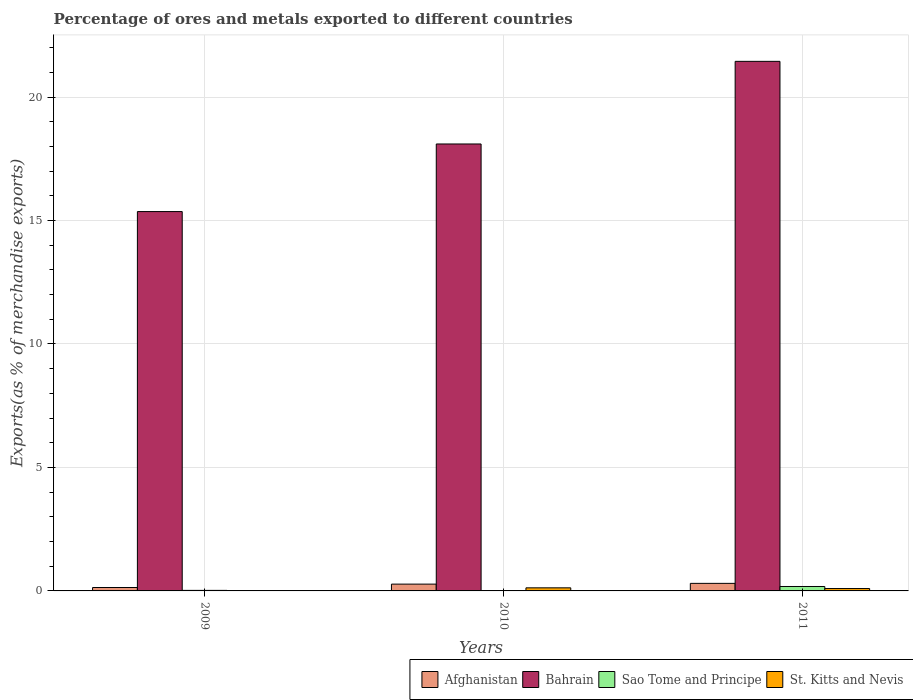How many different coloured bars are there?
Your response must be concise. 4. Are the number of bars on each tick of the X-axis equal?
Give a very brief answer. Yes. What is the percentage of exports to different countries in St. Kitts and Nevis in 2010?
Make the answer very short. 0.13. Across all years, what is the maximum percentage of exports to different countries in Afghanistan?
Your answer should be very brief. 0.31. Across all years, what is the minimum percentage of exports to different countries in Sao Tome and Principe?
Your response must be concise. 0.01. In which year was the percentage of exports to different countries in St. Kitts and Nevis maximum?
Provide a succinct answer. 2010. In which year was the percentage of exports to different countries in Bahrain minimum?
Make the answer very short. 2009. What is the total percentage of exports to different countries in Sao Tome and Principe in the graph?
Ensure brevity in your answer.  0.22. What is the difference between the percentage of exports to different countries in St. Kitts and Nevis in 2010 and that in 2011?
Offer a terse response. 0.03. What is the difference between the percentage of exports to different countries in Sao Tome and Principe in 2011 and the percentage of exports to different countries in Bahrain in 2010?
Make the answer very short. -17.92. What is the average percentage of exports to different countries in Afghanistan per year?
Offer a very short reply. 0.24. In the year 2010, what is the difference between the percentage of exports to different countries in Afghanistan and percentage of exports to different countries in Sao Tome and Principe?
Give a very brief answer. 0.26. What is the ratio of the percentage of exports to different countries in Afghanistan in 2009 to that in 2011?
Offer a very short reply. 0.45. Is the percentage of exports to different countries in St. Kitts and Nevis in 2009 less than that in 2010?
Your response must be concise. Yes. What is the difference between the highest and the second highest percentage of exports to different countries in St. Kitts and Nevis?
Your answer should be very brief. 0.03. What is the difference between the highest and the lowest percentage of exports to different countries in St. Kitts and Nevis?
Ensure brevity in your answer.  0.13. What does the 3rd bar from the left in 2010 represents?
Make the answer very short. Sao Tome and Principe. What does the 2nd bar from the right in 2011 represents?
Provide a short and direct response. Sao Tome and Principe. Are all the bars in the graph horizontal?
Make the answer very short. No. Does the graph contain any zero values?
Ensure brevity in your answer.  No. Does the graph contain grids?
Your answer should be compact. Yes. Where does the legend appear in the graph?
Ensure brevity in your answer.  Bottom right. What is the title of the graph?
Make the answer very short. Percentage of ores and metals exported to different countries. What is the label or title of the Y-axis?
Ensure brevity in your answer.  Exports(as % of merchandise exports). What is the Exports(as % of merchandise exports) in Afghanistan in 2009?
Your answer should be compact. 0.14. What is the Exports(as % of merchandise exports) in Bahrain in 2009?
Give a very brief answer. 15.36. What is the Exports(as % of merchandise exports) of Sao Tome and Principe in 2009?
Give a very brief answer. 0.02. What is the Exports(as % of merchandise exports) in St. Kitts and Nevis in 2009?
Ensure brevity in your answer.  5.4969756098276e-5. What is the Exports(as % of merchandise exports) in Afghanistan in 2010?
Your answer should be compact. 0.28. What is the Exports(as % of merchandise exports) of Bahrain in 2010?
Offer a terse response. 18.1. What is the Exports(as % of merchandise exports) of Sao Tome and Principe in 2010?
Your answer should be very brief. 0.01. What is the Exports(as % of merchandise exports) in St. Kitts and Nevis in 2010?
Keep it short and to the point. 0.13. What is the Exports(as % of merchandise exports) of Afghanistan in 2011?
Make the answer very short. 0.31. What is the Exports(as % of merchandise exports) of Bahrain in 2011?
Your answer should be compact. 21.45. What is the Exports(as % of merchandise exports) of Sao Tome and Principe in 2011?
Make the answer very short. 0.18. What is the Exports(as % of merchandise exports) of St. Kitts and Nevis in 2011?
Provide a short and direct response. 0.1. Across all years, what is the maximum Exports(as % of merchandise exports) in Afghanistan?
Offer a terse response. 0.31. Across all years, what is the maximum Exports(as % of merchandise exports) of Bahrain?
Make the answer very short. 21.45. Across all years, what is the maximum Exports(as % of merchandise exports) of Sao Tome and Principe?
Provide a succinct answer. 0.18. Across all years, what is the maximum Exports(as % of merchandise exports) in St. Kitts and Nevis?
Give a very brief answer. 0.13. Across all years, what is the minimum Exports(as % of merchandise exports) of Afghanistan?
Give a very brief answer. 0.14. Across all years, what is the minimum Exports(as % of merchandise exports) in Bahrain?
Your answer should be very brief. 15.36. Across all years, what is the minimum Exports(as % of merchandise exports) in Sao Tome and Principe?
Your response must be concise. 0.01. Across all years, what is the minimum Exports(as % of merchandise exports) in St. Kitts and Nevis?
Ensure brevity in your answer.  5.4969756098276e-5. What is the total Exports(as % of merchandise exports) in Afghanistan in the graph?
Offer a very short reply. 0.72. What is the total Exports(as % of merchandise exports) of Bahrain in the graph?
Your response must be concise. 54.91. What is the total Exports(as % of merchandise exports) in Sao Tome and Principe in the graph?
Offer a very short reply. 0.22. What is the total Exports(as % of merchandise exports) of St. Kitts and Nevis in the graph?
Make the answer very short. 0.22. What is the difference between the Exports(as % of merchandise exports) in Afghanistan in 2009 and that in 2010?
Keep it short and to the point. -0.14. What is the difference between the Exports(as % of merchandise exports) of Bahrain in 2009 and that in 2010?
Keep it short and to the point. -2.74. What is the difference between the Exports(as % of merchandise exports) of Sao Tome and Principe in 2009 and that in 2010?
Offer a very short reply. 0.01. What is the difference between the Exports(as % of merchandise exports) of St. Kitts and Nevis in 2009 and that in 2010?
Your answer should be compact. -0.13. What is the difference between the Exports(as % of merchandise exports) in Afghanistan in 2009 and that in 2011?
Offer a very short reply. -0.17. What is the difference between the Exports(as % of merchandise exports) in Bahrain in 2009 and that in 2011?
Provide a succinct answer. -6.08. What is the difference between the Exports(as % of merchandise exports) in Sao Tome and Principe in 2009 and that in 2011?
Your response must be concise. -0.16. What is the difference between the Exports(as % of merchandise exports) of St. Kitts and Nevis in 2009 and that in 2011?
Offer a terse response. -0.1. What is the difference between the Exports(as % of merchandise exports) of Afghanistan in 2010 and that in 2011?
Provide a short and direct response. -0.03. What is the difference between the Exports(as % of merchandise exports) of Bahrain in 2010 and that in 2011?
Your response must be concise. -3.35. What is the difference between the Exports(as % of merchandise exports) in Sao Tome and Principe in 2010 and that in 2011?
Offer a terse response. -0.16. What is the difference between the Exports(as % of merchandise exports) of St. Kitts and Nevis in 2010 and that in 2011?
Your answer should be very brief. 0.03. What is the difference between the Exports(as % of merchandise exports) in Afghanistan in 2009 and the Exports(as % of merchandise exports) in Bahrain in 2010?
Offer a very short reply. -17.96. What is the difference between the Exports(as % of merchandise exports) in Afghanistan in 2009 and the Exports(as % of merchandise exports) in Sao Tome and Principe in 2010?
Make the answer very short. 0.12. What is the difference between the Exports(as % of merchandise exports) of Afghanistan in 2009 and the Exports(as % of merchandise exports) of St. Kitts and Nevis in 2010?
Your answer should be very brief. 0.01. What is the difference between the Exports(as % of merchandise exports) in Bahrain in 2009 and the Exports(as % of merchandise exports) in Sao Tome and Principe in 2010?
Make the answer very short. 15.35. What is the difference between the Exports(as % of merchandise exports) in Bahrain in 2009 and the Exports(as % of merchandise exports) in St. Kitts and Nevis in 2010?
Provide a short and direct response. 15.24. What is the difference between the Exports(as % of merchandise exports) of Sao Tome and Principe in 2009 and the Exports(as % of merchandise exports) of St. Kitts and Nevis in 2010?
Your response must be concise. -0.1. What is the difference between the Exports(as % of merchandise exports) in Afghanistan in 2009 and the Exports(as % of merchandise exports) in Bahrain in 2011?
Your answer should be compact. -21.31. What is the difference between the Exports(as % of merchandise exports) of Afghanistan in 2009 and the Exports(as % of merchandise exports) of Sao Tome and Principe in 2011?
Offer a very short reply. -0.04. What is the difference between the Exports(as % of merchandise exports) in Afghanistan in 2009 and the Exports(as % of merchandise exports) in St. Kitts and Nevis in 2011?
Offer a very short reply. 0.04. What is the difference between the Exports(as % of merchandise exports) in Bahrain in 2009 and the Exports(as % of merchandise exports) in Sao Tome and Principe in 2011?
Provide a succinct answer. 15.18. What is the difference between the Exports(as % of merchandise exports) in Bahrain in 2009 and the Exports(as % of merchandise exports) in St. Kitts and Nevis in 2011?
Give a very brief answer. 15.27. What is the difference between the Exports(as % of merchandise exports) of Sao Tome and Principe in 2009 and the Exports(as % of merchandise exports) of St. Kitts and Nevis in 2011?
Provide a succinct answer. -0.07. What is the difference between the Exports(as % of merchandise exports) of Afghanistan in 2010 and the Exports(as % of merchandise exports) of Bahrain in 2011?
Offer a very short reply. -21.17. What is the difference between the Exports(as % of merchandise exports) in Afghanistan in 2010 and the Exports(as % of merchandise exports) in Sao Tome and Principe in 2011?
Your answer should be compact. 0.1. What is the difference between the Exports(as % of merchandise exports) of Afghanistan in 2010 and the Exports(as % of merchandise exports) of St. Kitts and Nevis in 2011?
Make the answer very short. 0.18. What is the difference between the Exports(as % of merchandise exports) in Bahrain in 2010 and the Exports(as % of merchandise exports) in Sao Tome and Principe in 2011?
Keep it short and to the point. 17.92. What is the difference between the Exports(as % of merchandise exports) in Bahrain in 2010 and the Exports(as % of merchandise exports) in St. Kitts and Nevis in 2011?
Offer a terse response. 18. What is the difference between the Exports(as % of merchandise exports) in Sao Tome and Principe in 2010 and the Exports(as % of merchandise exports) in St. Kitts and Nevis in 2011?
Offer a terse response. -0.08. What is the average Exports(as % of merchandise exports) in Afghanistan per year?
Provide a succinct answer. 0.24. What is the average Exports(as % of merchandise exports) of Bahrain per year?
Make the answer very short. 18.3. What is the average Exports(as % of merchandise exports) in Sao Tome and Principe per year?
Offer a terse response. 0.07. What is the average Exports(as % of merchandise exports) of St. Kitts and Nevis per year?
Make the answer very short. 0.07. In the year 2009, what is the difference between the Exports(as % of merchandise exports) of Afghanistan and Exports(as % of merchandise exports) of Bahrain?
Your answer should be compact. -15.22. In the year 2009, what is the difference between the Exports(as % of merchandise exports) in Afghanistan and Exports(as % of merchandise exports) in Sao Tome and Principe?
Make the answer very short. 0.12. In the year 2009, what is the difference between the Exports(as % of merchandise exports) in Afghanistan and Exports(as % of merchandise exports) in St. Kitts and Nevis?
Your answer should be very brief. 0.14. In the year 2009, what is the difference between the Exports(as % of merchandise exports) in Bahrain and Exports(as % of merchandise exports) in Sao Tome and Principe?
Keep it short and to the point. 15.34. In the year 2009, what is the difference between the Exports(as % of merchandise exports) in Bahrain and Exports(as % of merchandise exports) in St. Kitts and Nevis?
Make the answer very short. 15.36. In the year 2009, what is the difference between the Exports(as % of merchandise exports) of Sao Tome and Principe and Exports(as % of merchandise exports) of St. Kitts and Nevis?
Your answer should be compact. 0.02. In the year 2010, what is the difference between the Exports(as % of merchandise exports) in Afghanistan and Exports(as % of merchandise exports) in Bahrain?
Your response must be concise. -17.82. In the year 2010, what is the difference between the Exports(as % of merchandise exports) of Afghanistan and Exports(as % of merchandise exports) of Sao Tome and Principe?
Give a very brief answer. 0.26. In the year 2010, what is the difference between the Exports(as % of merchandise exports) of Afghanistan and Exports(as % of merchandise exports) of St. Kitts and Nevis?
Your answer should be very brief. 0.15. In the year 2010, what is the difference between the Exports(as % of merchandise exports) of Bahrain and Exports(as % of merchandise exports) of Sao Tome and Principe?
Provide a succinct answer. 18.08. In the year 2010, what is the difference between the Exports(as % of merchandise exports) of Bahrain and Exports(as % of merchandise exports) of St. Kitts and Nevis?
Your response must be concise. 17.97. In the year 2010, what is the difference between the Exports(as % of merchandise exports) of Sao Tome and Principe and Exports(as % of merchandise exports) of St. Kitts and Nevis?
Give a very brief answer. -0.11. In the year 2011, what is the difference between the Exports(as % of merchandise exports) in Afghanistan and Exports(as % of merchandise exports) in Bahrain?
Provide a succinct answer. -21.14. In the year 2011, what is the difference between the Exports(as % of merchandise exports) of Afghanistan and Exports(as % of merchandise exports) of Sao Tome and Principe?
Give a very brief answer. 0.13. In the year 2011, what is the difference between the Exports(as % of merchandise exports) in Afghanistan and Exports(as % of merchandise exports) in St. Kitts and Nevis?
Your response must be concise. 0.21. In the year 2011, what is the difference between the Exports(as % of merchandise exports) of Bahrain and Exports(as % of merchandise exports) of Sao Tome and Principe?
Your answer should be compact. 21.27. In the year 2011, what is the difference between the Exports(as % of merchandise exports) of Bahrain and Exports(as % of merchandise exports) of St. Kitts and Nevis?
Give a very brief answer. 21.35. In the year 2011, what is the difference between the Exports(as % of merchandise exports) in Sao Tome and Principe and Exports(as % of merchandise exports) in St. Kitts and Nevis?
Give a very brief answer. 0.08. What is the ratio of the Exports(as % of merchandise exports) of Afghanistan in 2009 to that in 2010?
Your answer should be very brief. 0.5. What is the ratio of the Exports(as % of merchandise exports) in Bahrain in 2009 to that in 2010?
Provide a short and direct response. 0.85. What is the ratio of the Exports(as % of merchandise exports) in Sao Tome and Principe in 2009 to that in 2010?
Offer a very short reply. 1.49. What is the ratio of the Exports(as % of merchandise exports) in St. Kitts and Nevis in 2009 to that in 2010?
Your response must be concise. 0. What is the ratio of the Exports(as % of merchandise exports) in Afghanistan in 2009 to that in 2011?
Keep it short and to the point. 0.45. What is the ratio of the Exports(as % of merchandise exports) of Bahrain in 2009 to that in 2011?
Your answer should be very brief. 0.72. What is the ratio of the Exports(as % of merchandise exports) in Sao Tome and Principe in 2009 to that in 2011?
Provide a short and direct response. 0.12. What is the ratio of the Exports(as % of merchandise exports) of St. Kitts and Nevis in 2009 to that in 2011?
Give a very brief answer. 0. What is the ratio of the Exports(as % of merchandise exports) of Afghanistan in 2010 to that in 2011?
Provide a succinct answer. 0.9. What is the ratio of the Exports(as % of merchandise exports) in Bahrain in 2010 to that in 2011?
Give a very brief answer. 0.84. What is the ratio of the Exports(as % of merchandise exports) in Sao Tome and Principe in 2010 to that in 2011?
Provide a succinct answer. 0.08. What is the ratio of the Exports(as % of merchandise exports) in St. Kitts and Nevis in 2010 to that in 2011?
Offer a terse response. 1.29. What is the difference between the highest and the second highest Exports(as % of merchandise exports) in Afghanistan?
Offer a very short reply. 0.03. What is the difference between the highest and the second highest Exports(as % of merchandise exports) in Bahrain?
Make the answer very short. 3.35. What is the difference between the highest and the second highest Exports(as % of merchandise exports) in Sao Tome and Principe?
Provide a succinct answer. 0.16. What is the difference between the highest and the second highest Exports(as % of merchandise exports) of St. Kitts and Nevis?
Ensure brevity in your answer.  0.03. What is the difference between the highest and the lowest Exports(as % of merchandise exports) in Afghanistan?
Ensure brevity in your answer.  0.17. What is the difference between the highest and the lowest Exports(as % of merchandise exports) in Bahrain?
Keep it short and to the point. 6.08. What is the difference between the highest and the lowest Exports(as % of merchandise exports) in Sao Tome and Principe?
Ensure brevity in your answer.  0.16. What is the difference between the highest and the lowest Exports(as % of merchandise exports) in St. Kitts and Nevis?
Make the answer very short. 0.13. 